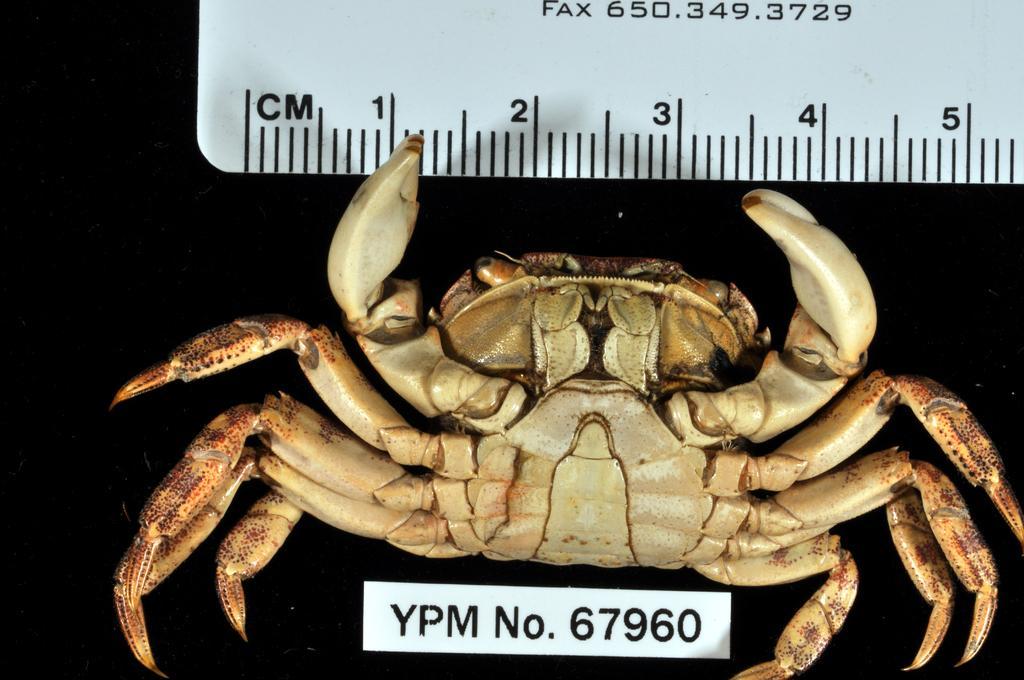Describe this image in one or two sentences. In this image I can see the crab in cream and brown color. I can see the white color scale and something is written on it. Background is in black color. 